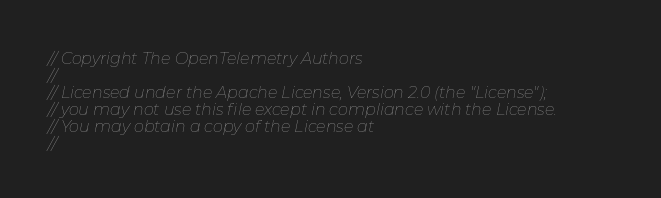Convert code to text. <code><loc_0><loc_0><loc_500><loc_500><_Go_>// Copyright The OpenTelemetry Authors
//
// Licensed under the Apache License, Version 2.0 (the "License");
// you may not use this file except in compliance with the License.
// You may obtain a copy of the License at
//</code> 